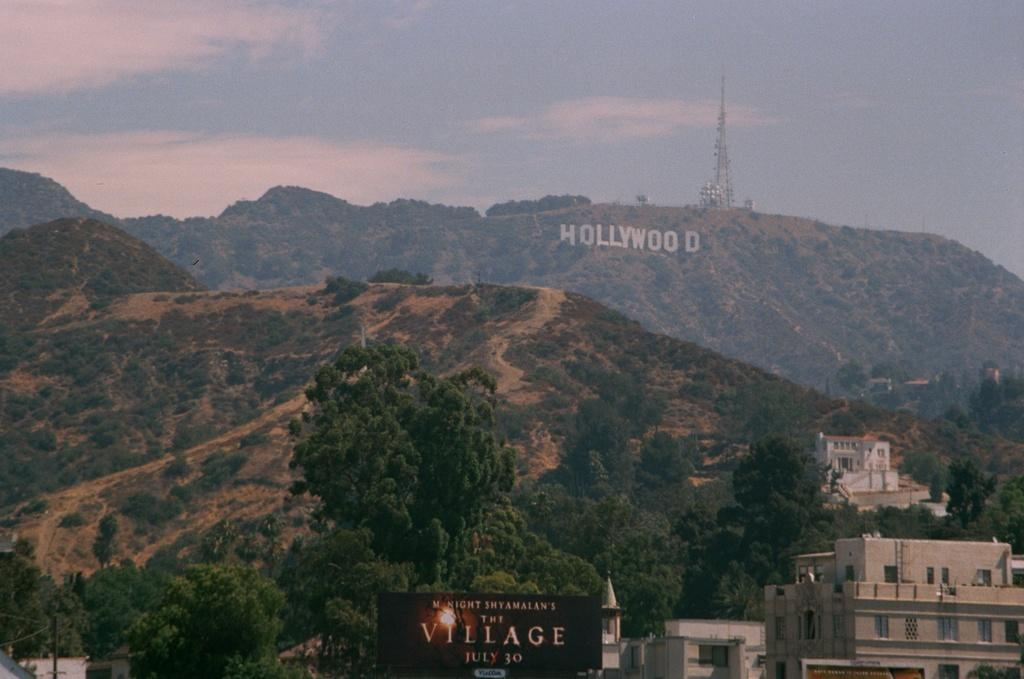What type of natural formation is in the center of the image? There are hills in the center of the image. What structures can be seen on the right side of the image? There are buildings on the right side of the image. What is located at the bottom of the image? There is a board at the bottom of the image. What type of communication infrastructure is present in the background of the image? There is a mobile tower in the background of the image. What is visible in the background of the image? The sky is visible in the background of the image. What type of produce is being harvested on the left side of the image? There is no produce or harvesting activity depicted in the image. How many pages are visible in the image? There are no pages present in the image. 